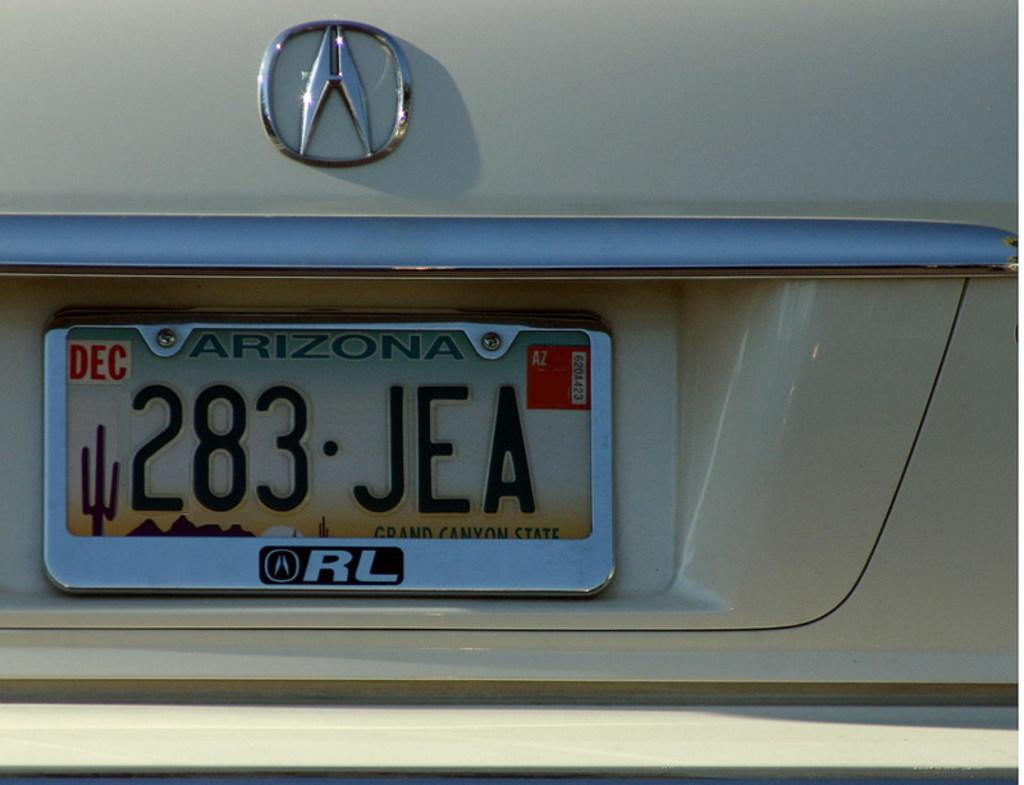Provide a one-sentence caption for the provided image. The Arizona license plate read 283 JEA  on a tan vehicle. 